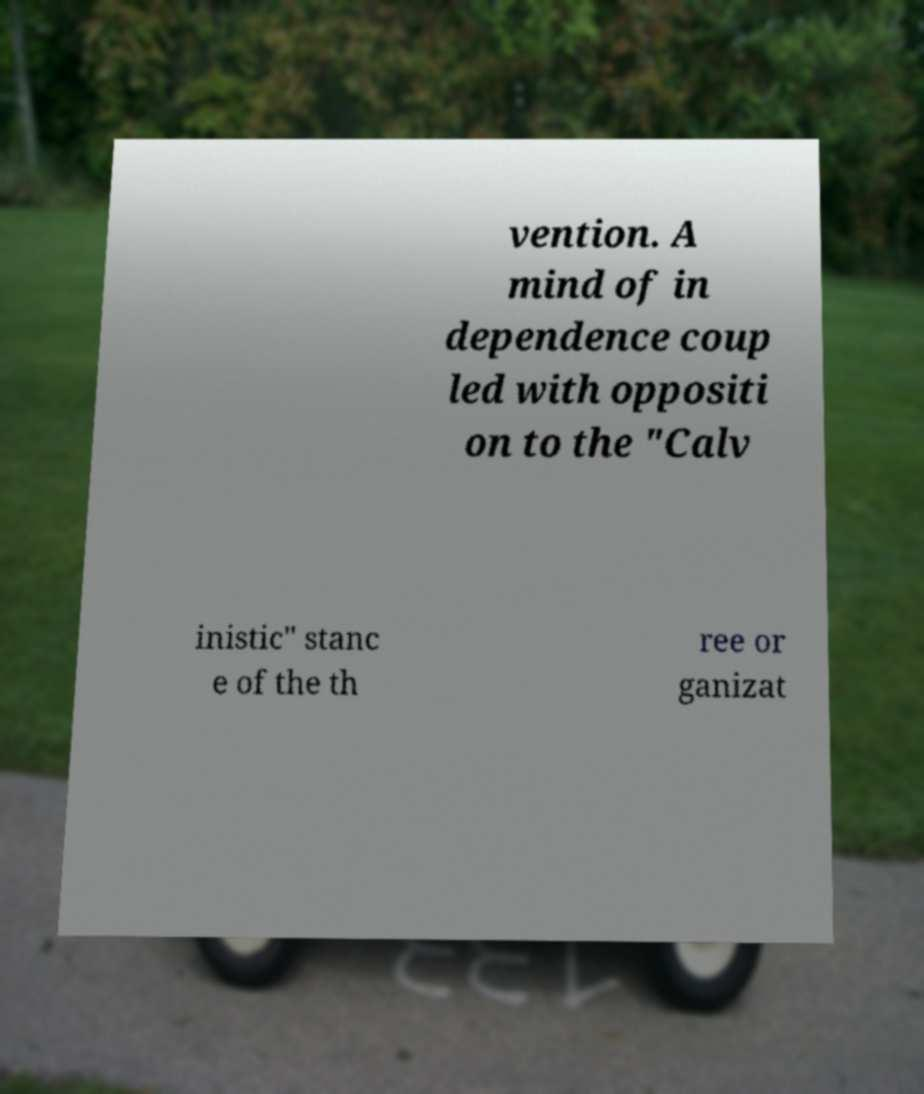Please identify and transcribe the text found in this image. vention. A mind of in dependence coup led with oppositi on to the "Calv inistic" stanc e of the th ree or ganizat 